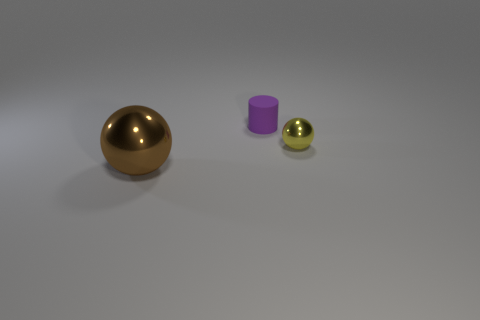Add 2 small gray metallic balls. How many objects exist? 5 Subtract all balls. How many objects are left? 1 Subtract 0 blue cylinders. How many objects are left? 3 Subtract all purple matte blocks. Subtract all metal things. How many objects are left? 1 Add 3 tiny matte cylinders. How many tiny matte cylinders are left? 4 Add 3 large brown objects. How many large brown objects exist? 4 